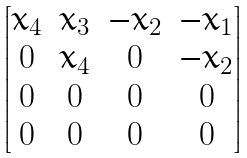<formula> <loc_0><loc_0><loc_500><loc_500>\begin{bmatrix} x _ { 4 } & x _ { 3 } & - x _ { 2 } & - x _ { 1 } \\ 0 & x _ { 4 } & 0 & - x _ { 2 } \\ 0 & 0 & 0 & 0 \\ 0 & 0 & 0 & 0 \end{bmatrix}</formula> 